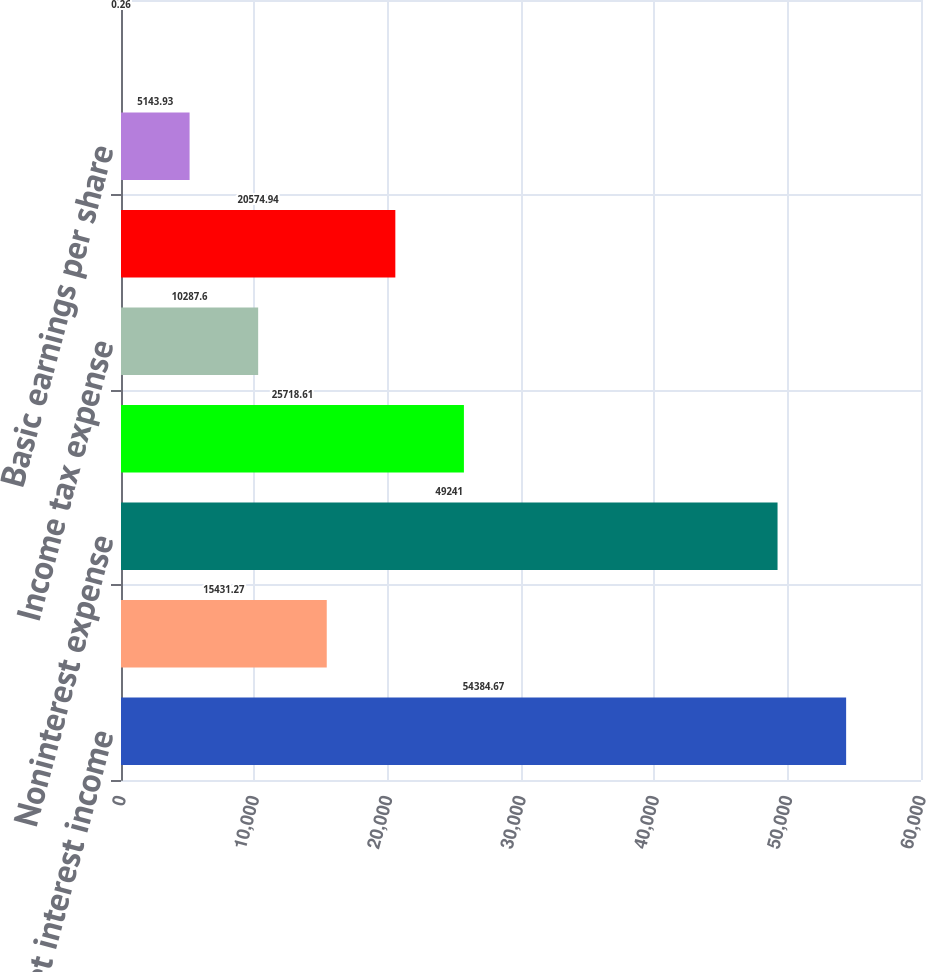Convert chart to OTSL. <chart><loc_0><loc_0><loc_500><loc_500><bar_chart><fcel>Net interest income<fcel>Noninterest income<fcel>Noninterest expense<fcel>Income before income tax<fcel>Income tax expense<fcel>Net income<fcel>Basic earnings per share<fcel>Diluted earnings per share<nl><fcel>54384.7<fcel>15431.3<fcel>49241<fcel>25718.6<fcel>10287.6<fcel>20574.9<fcel>5143.93<fcel>0.26<nl></chart> 